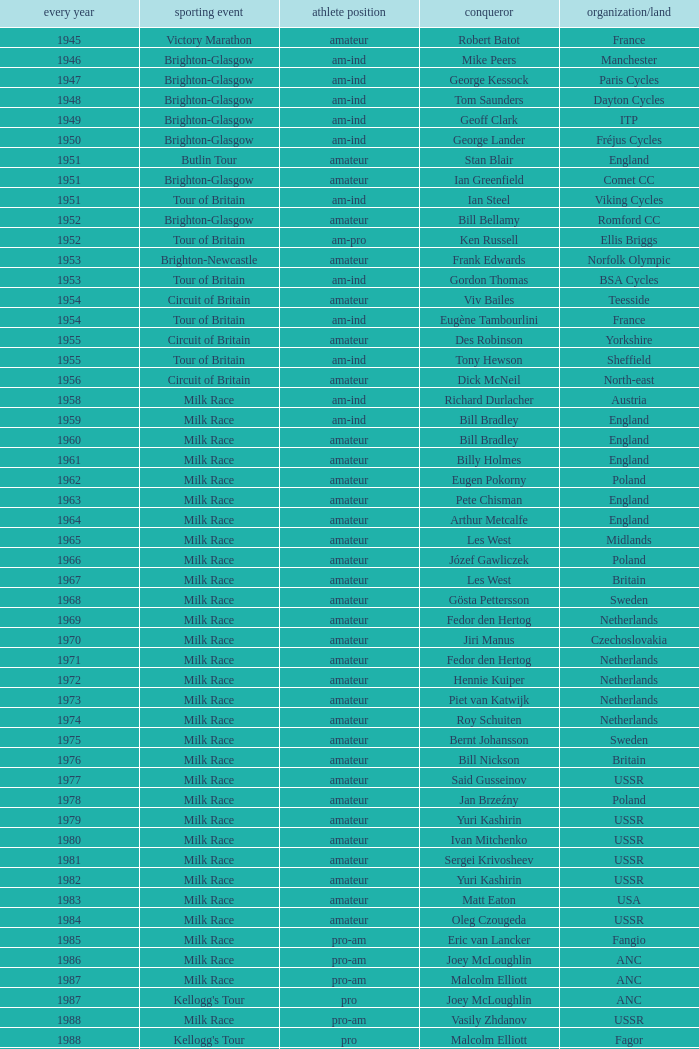What ream played later than 1958 in the kellogg's tour? ANC, Fagor, Z-Peugeot, Weinnmann-SMM, Motorola, Motorola, Motorola, Lampre. 